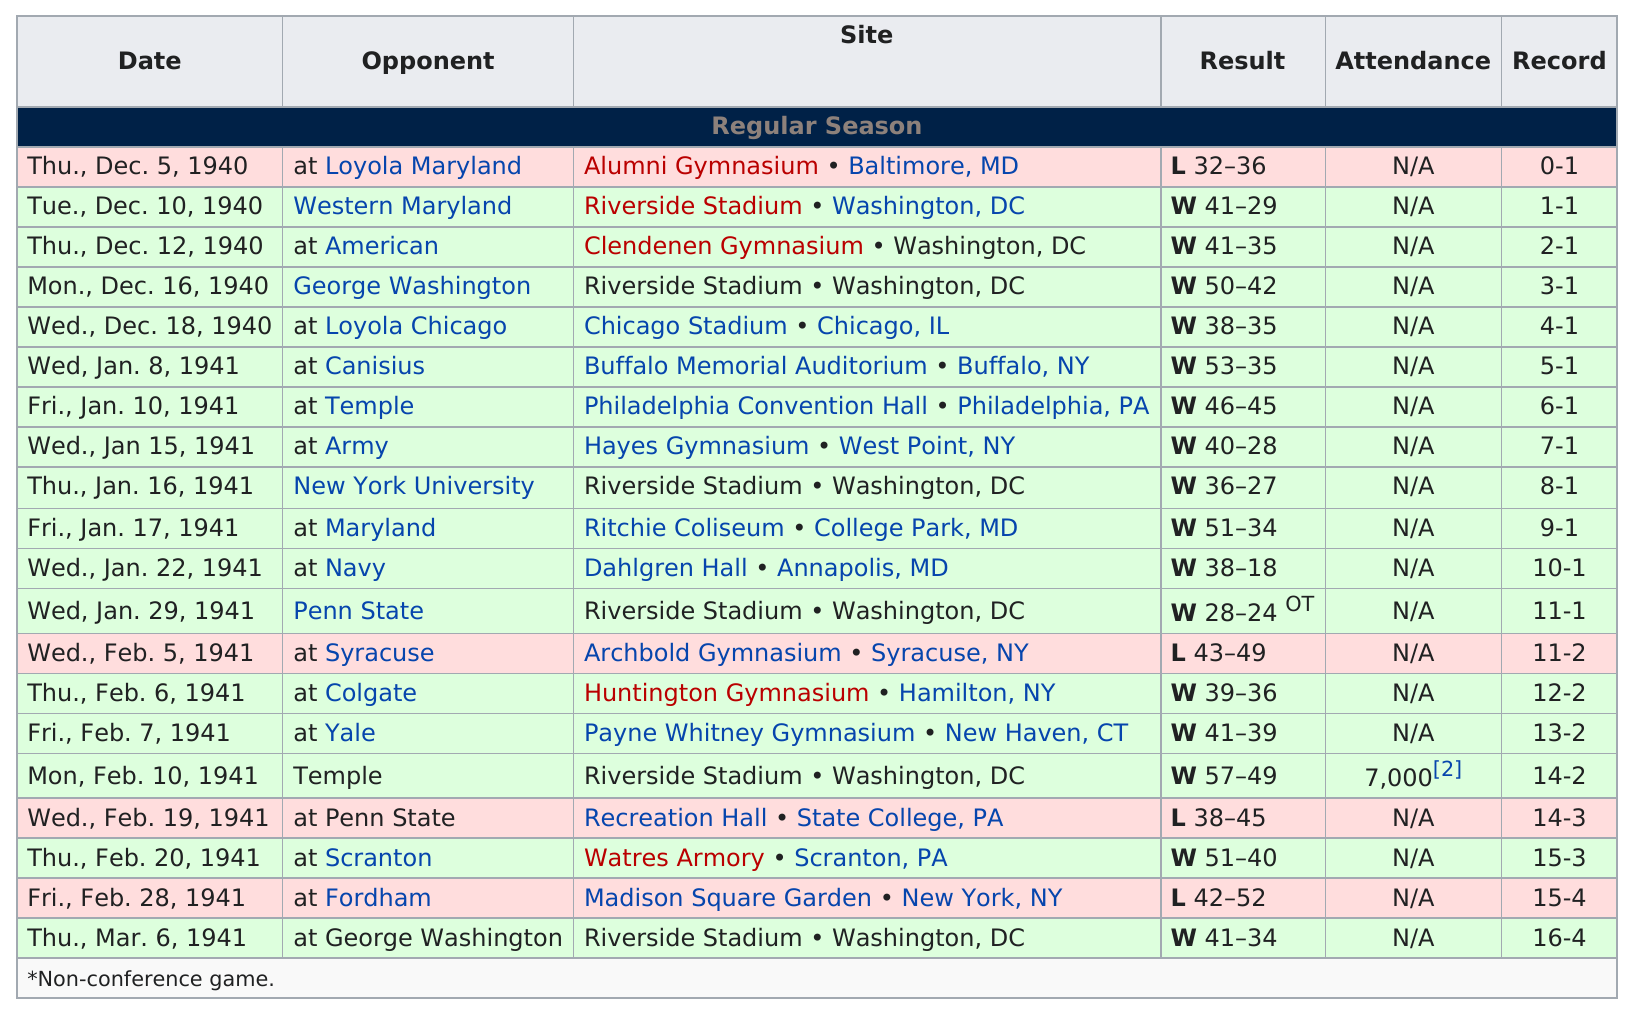Give some essential details in this illustration. The number 7,000 is the only attendance listed. The army came before the navy, as the first in military history. The Hoyas lost a total of 4 away games. During the 2022-2023 season, the Georgetown Hoyas achieved a remarkable 11 consecutive wins. In February, they played a total of 7 games. 